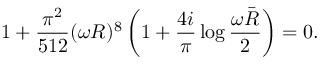<formula> <loc_0><loc_0><loc_500><loc_500>1 + \frac { \pi ^ { 2 } } { 5 1 2 } ( \omega R ) ^ { 8 } \left ( 1 + \frac { 4 i } { \pi } \log \frac { \omega \bar { R } } { 2 } \right ) = 0 .</formula> 